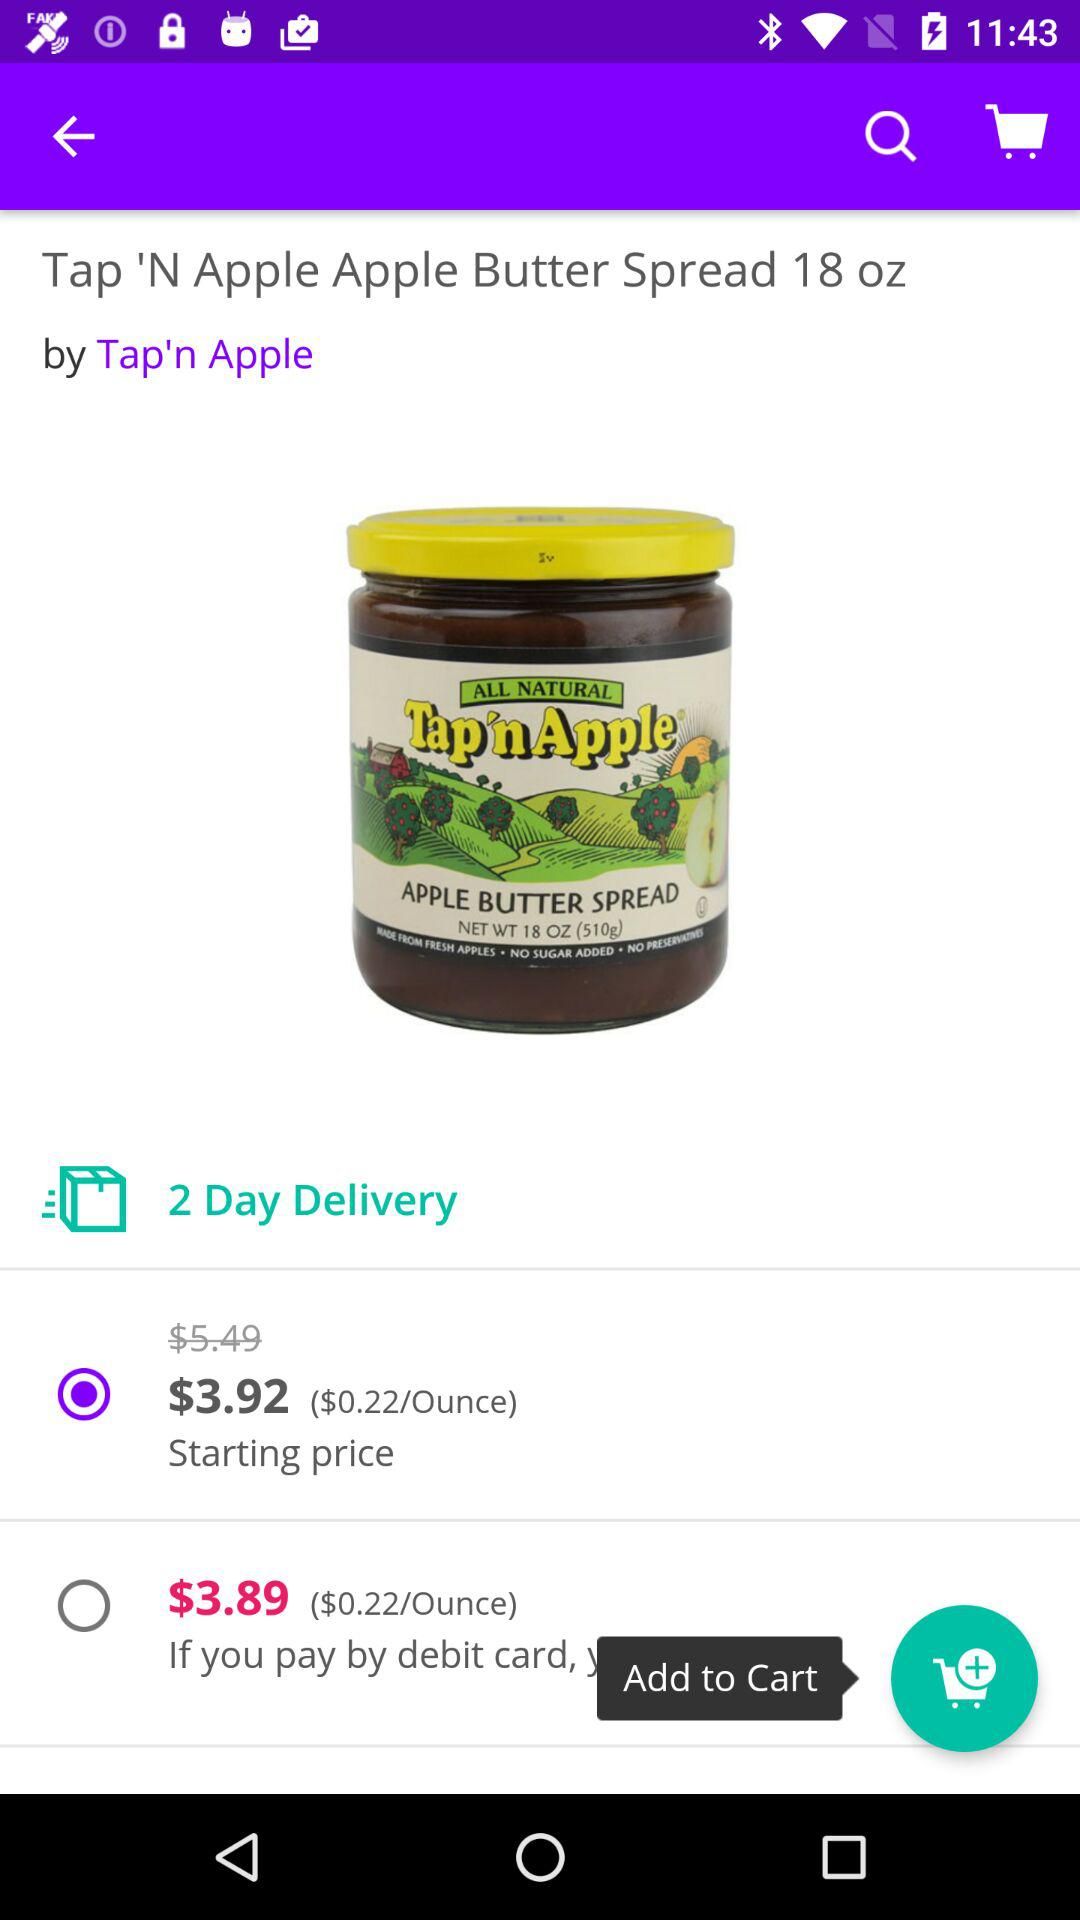What is the weight of the "N Apple Butter Spread" jar? The weight of the "N Apple Butter Spread" jar is 18 oz. 